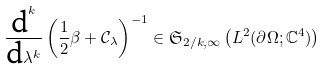Convert formula to latex. <formula><loc_0><loc_0><loc_500><loc_500>\frac { \text {d} ^ { k } } { \text {d} \lambda ^ { k } } \left ( \frac { 1 } { 2 } \beta + \mathcal { C } _ { \lambda } \right ) ^ { - 1 } \in \mathfrak { S } _ { 2 / k , \infty } \left ( L ^ { 2 } ( \partial \Omega ; \mathbb { C } ^ { 4 } ) \right )</formula> 